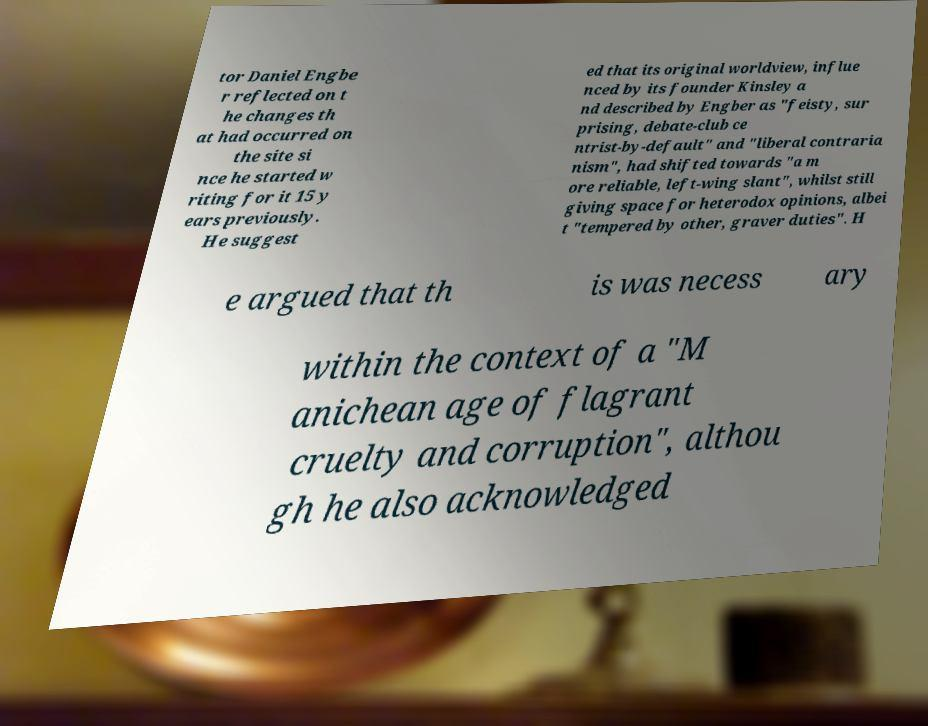What messages or text are displayed in this image? I need them in a readable, typed format. tor Daniel Engbe r reflected on t he changes th at had occurred on the site si nce he started w riting for it 15 y ears previously. He suggest ed that its original worldview, influe nced by its founder Kinsley a nd described by Engber as "feisty, sur prising, debate-club ce ntrist-by-default" and "liberal contraria nism", had shifted towards "a m ore reliable, left-wing slant", whilst still giving space for heterodox opinions, albei t "tempered by other, graver duties". H e argued that th is was necess ary within the context of a "M anichean age of flagrant cruelty and corruption", althou gh he also acknowledged 